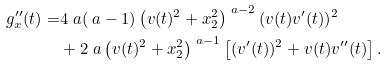Convert formula to latex. <formula><loc_0><loc_0><loc_500><loc_500>g _ { x } ^ { \prime \prime } ( t ) = & 4 \ a ( \ a - 1 ) \left ( v ( t ) ^ { 2 } + x _ { 2 } ^ { 2 } \right ) ^ { \ a - 2 } ( v ( t ) v ^ { \prime } ( t ) ) ^ { 2 } \\ & + 2 \ a \left ( v ( t ) ^ { 2 } + x _ { 2 } ^ { 2 } \right ) ^ { \ a - 1 } \left [ ( v ^ { \prime } ( t ) ) ^ { 2 } + v ( t ) v ^ { \prime \prime } ( t ) \right ] .</formula> 